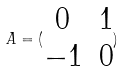<formula> <loc_0><loc_0><loc_500><loc_500>A = ( \begin{matrix} 0 & 1 \\ - 1 & 0 \end{matrix} )</formula> 